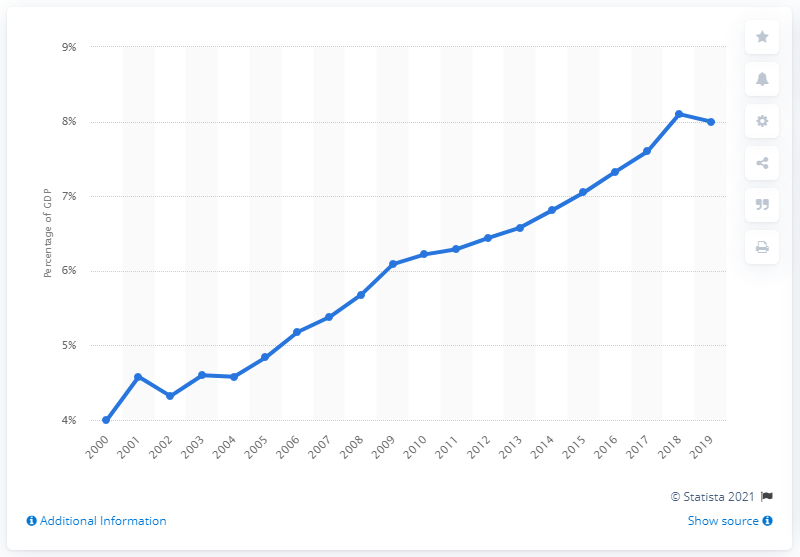Give some essential details in this illustration. In 2019, the amount of South Korea's Gross Domestic Product (GDP) that was spent on healthcare was approximately 8%. 